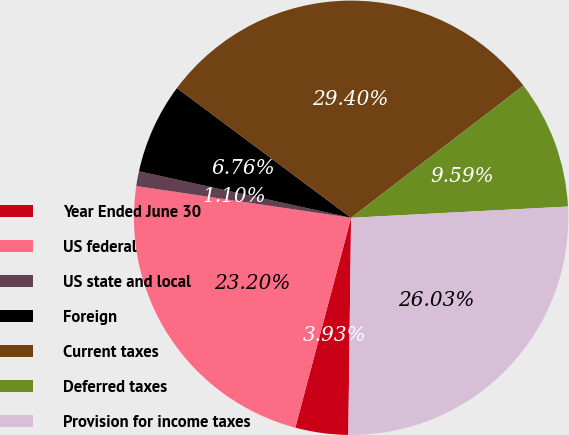Convert chart to OTSL. <chart><loc_0><loc_0><loc_500><loc_500><pie_chart><fcel>Year Ended June 30<fcel>US federal<fcel>US state and local<fcel>Foreign<fcel>Current taxes<fcel>Deferred taxes<fcel>Provision for income taxes<nl><fcel>3.93%<fcel>23.2%<fcel>1.1%<fcel>6.76%<fcel>29.4%<fcel>9.59%<fcel>26.03%<nl></chart> 